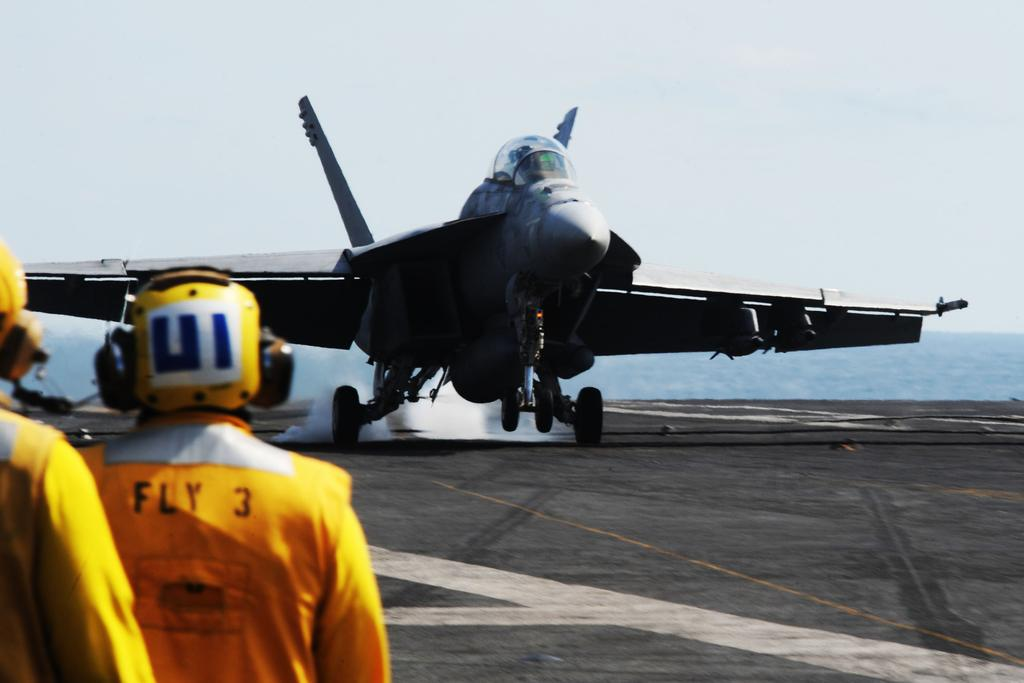<image>
Provide a brief description of the given image. a man watching an airplane land has FLY 3 on his jumpsuit 